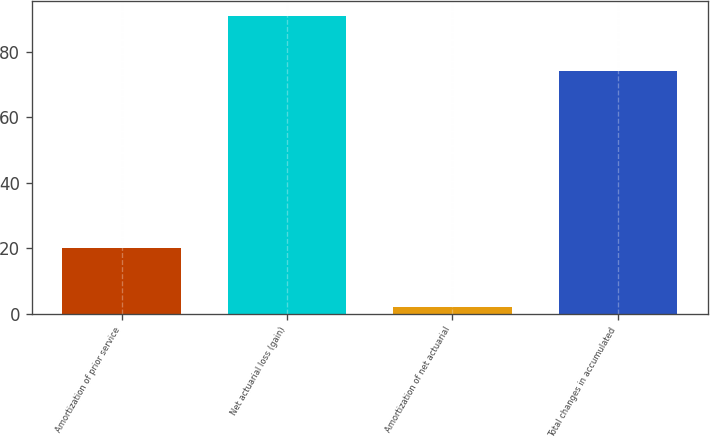Convert chart to OTSL. <chart><loc_0><loc_0><loc_500><loc_500><bar_chart><fcel>Amortization of prior service<fcel>Net actuarial loss (gain)<fcel>Amortization of net actuarial<fcel>Total changes in accumulated<nl><fcel>20<fcel>91<fcel>2<fcel>74<nl></chart> 